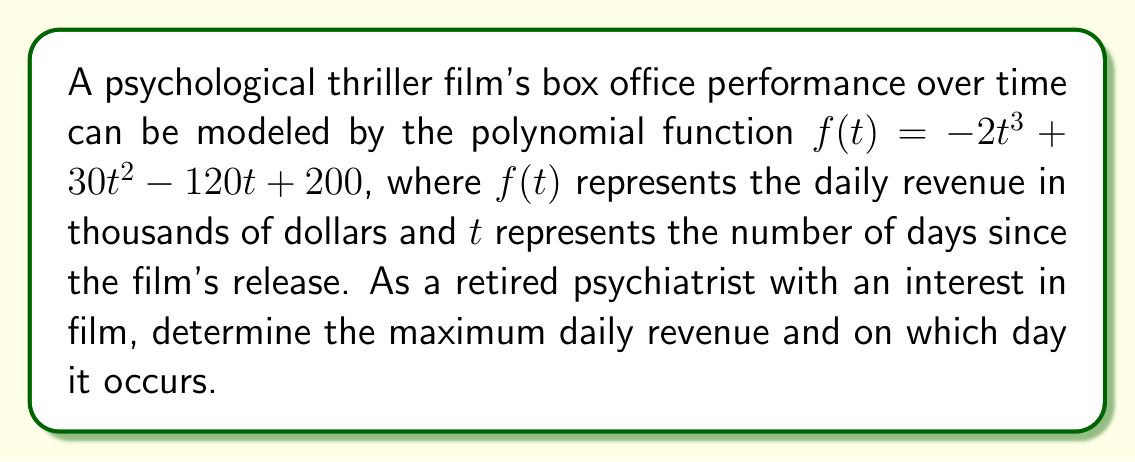Show me your answer to this math problem. To find the maximum point of this polynomial function, we need to follow these steps:

1) First, we need to find the derivative of the function:
   $f'(t) = -6t^2 + 60t - 120$

2) To find the critical points, we set the derivative equal to zero:
   $-6t^2 + 60t - 120 = 0$

3) This is a quadratic equation. We can solve it using the quadratic formula:
   $t = \frac{-b \pm \sqrt{b^2 - 4ac}}{2a}$

   Where $a = -6$, $b = 60$, and $c = -120$

4) Plugging in these values:
   $t = \frac{-60 \pm \sqrt{60^2 - 4(-6)(-120)}}{2(-6)}$
   $= \frac{-60 \pm \sqrt{3600 - 2880}}{-12}$
   $= \frac{-60 \pm \sqrt{720}}{-12}$
   $= \frac{-60 \pm 26.83}{-12}$

5) This gives us two solutions:
   $t_1 = \frac{-60 + 26.83}{-12} \approx 2.76$
   $t_2 = \frac{-60 - 26.83}{-12} \approx 7.24$

6) To determine which of these is the maximum point, we can check the second derivative:
   $f''(t) = -12t + 60$

   At $t = 2.76$: $f''(2.76) = -12(2.76) + 60 \approx 26.88 > 0$
   This indicates that $t = 2.76$ is a local minimum.

   At $t = 7.24$: $f''(7.24) = -12(7.24) + 60 \approx -26.88 < 0$
   This indicates that $t = 7.24$ is a local maximum.

7) Therefore, the maximum occurs at $t \approx 7.24$ days.

8) To find the maximum revenue, we plug this value back into our original function:
   $f(7.24) = -2(7.24)^3 + 30(7.24)^2 - 120(7.24) + 200$
   $\approx 306.31$ thousand dollars
Answer: The maximum daily revenue of approximately $306,310 occurs on day 7 (more precisely, 7.24 days) after the film's release. 